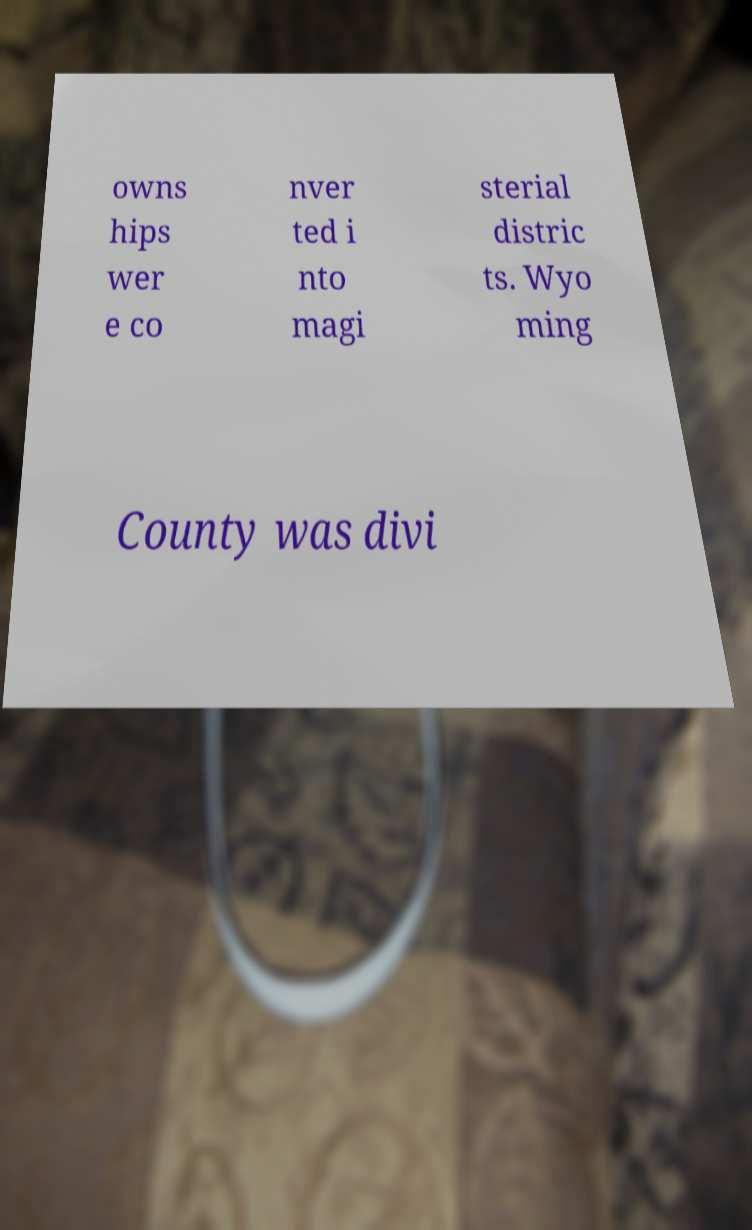I need the written content from this picture converted into text. Can you do that? owns hips wer e co nver ted i nto magi sterial distric ts. Wyo ming County was divi 